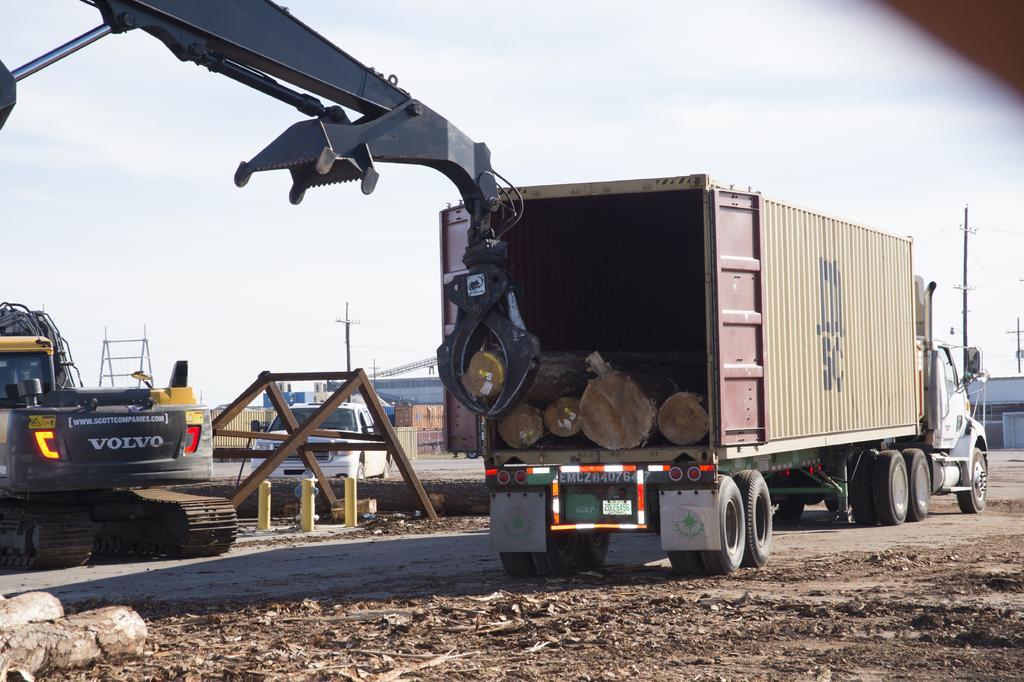How would you summarize this image in a sentence or two? This picture is clicked outside. In the center we can see the group of vehicles and we can see the metal rods and some other objects. In the background we can see the sky, houses and some other items. 